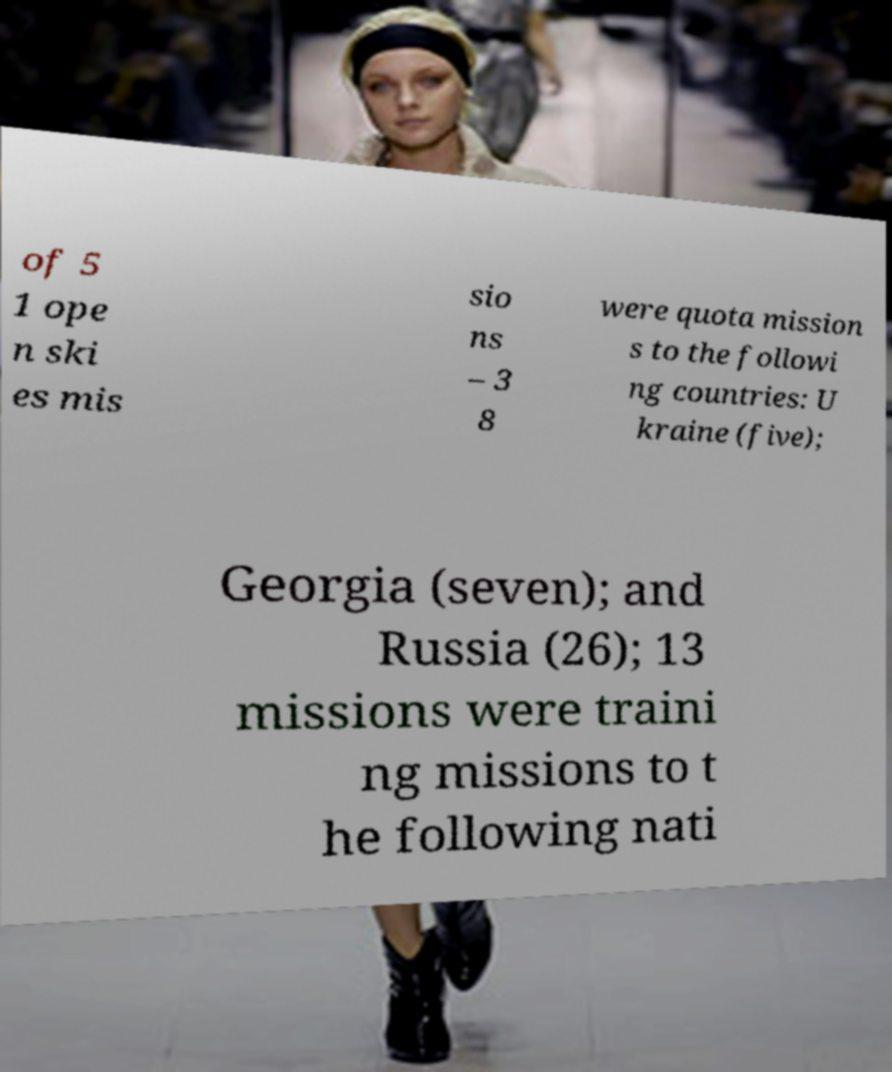What messages or text are displayed in this image? I need them in a readable, typed format. of 5 1 ope n ski es mis sio ns – 3 8 were quota mission s to the followi ng countries: U kraine (five); Georgia (seven); and Russia (26); 13 missions were traini ng missions to t he following nati 